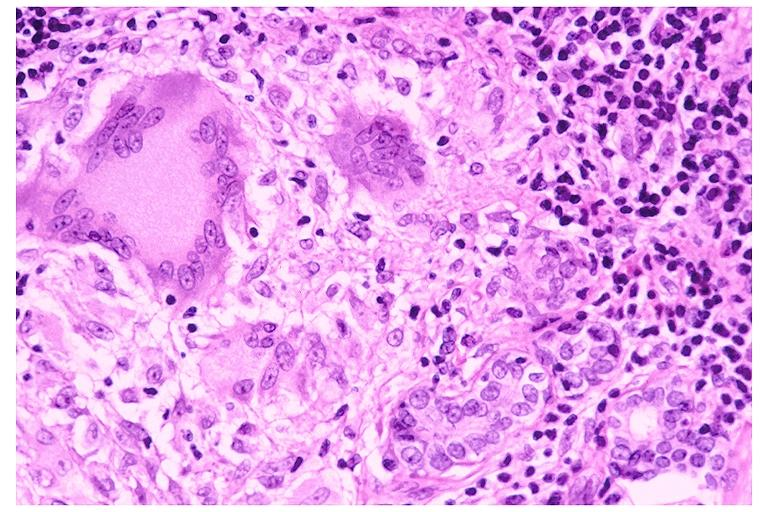s disease present?
Answer the question using a single word or phrase. No 